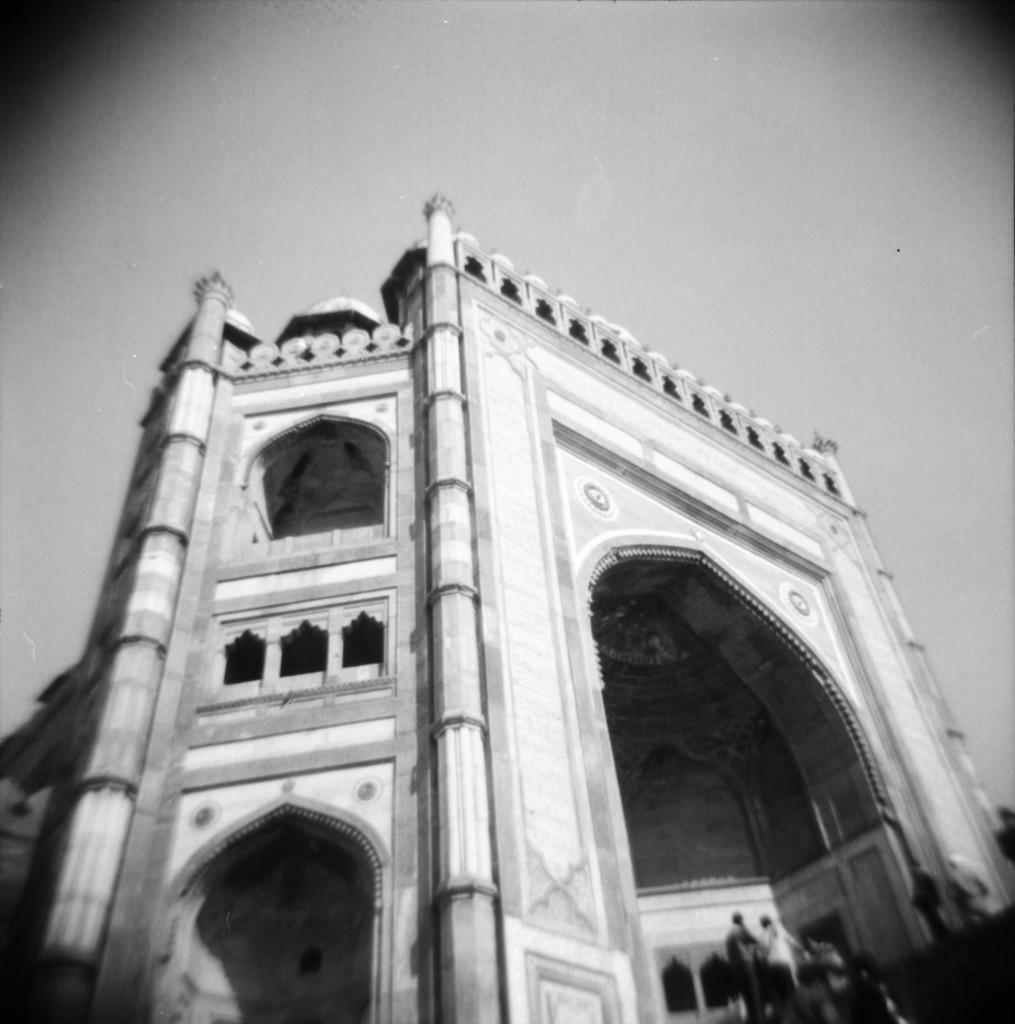What is the color scheme of the image? The image is black and white. What type of structure can be seen in the image? There is a building in the image. Are there any living beings present in the image? Yes, there are people in the image. What part of the natural environment is visible in the image? The sky is visible in the image. What type of quiver is being used by the people in the image? There is no quiver present in the image; it is a black and white image featuring a building, people, and the sky. 